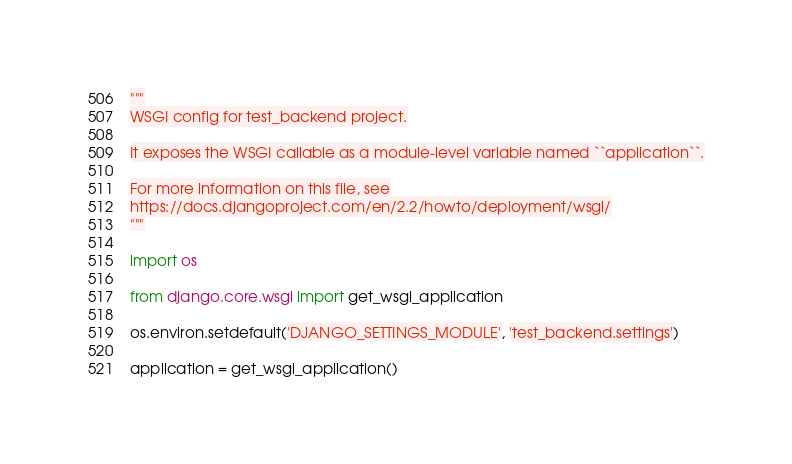Convert code to text. <code><loc_0><loc_0><loc_500><loc_500><_Python_>"""
WSGI config for test_backend project.

It exposes the WSGI callable as a module-level variable named ``application``.

For more information on this file, see
https://docs.djangoproject.com/en/2.2/howto/deployment/wsgi/
"""

import os

from django.core.wsgi import get_wsgi_application

os.environ.setdefault('DJANGO_SETTINGS_MODULE', 'test_backend.settings')

application = get_wsgi_application()
</code> 